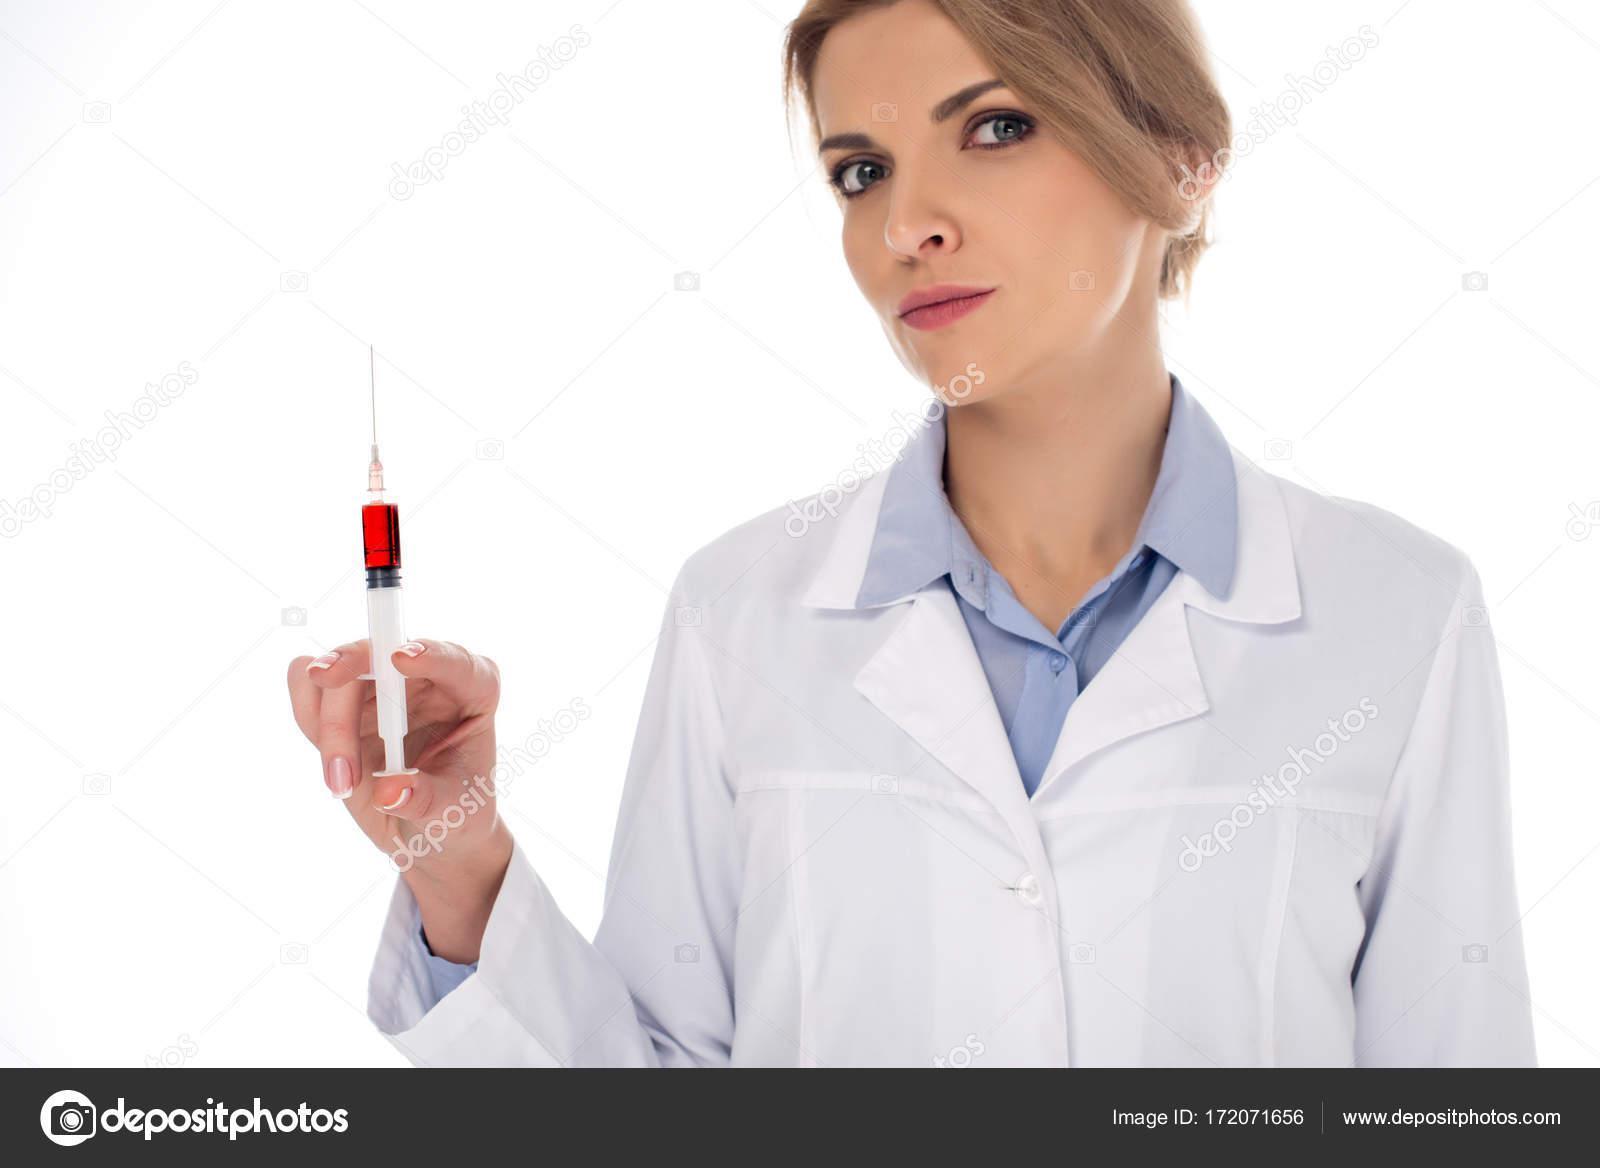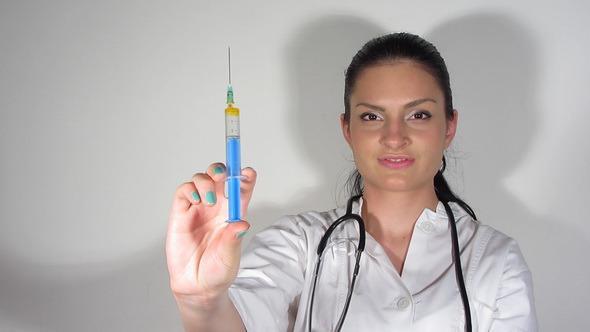The first image is the image on the left, the second image is the image on the right. For the images shown, is this caption "A woman is wearing a stethoscope in the image on the right." true? Answer yes or no. Yes. The first image is the image on the left, the second image is the image on the right. For the images shown, is this caption "A doctor is looking at a syringe." true? Answer yes or no. No. 